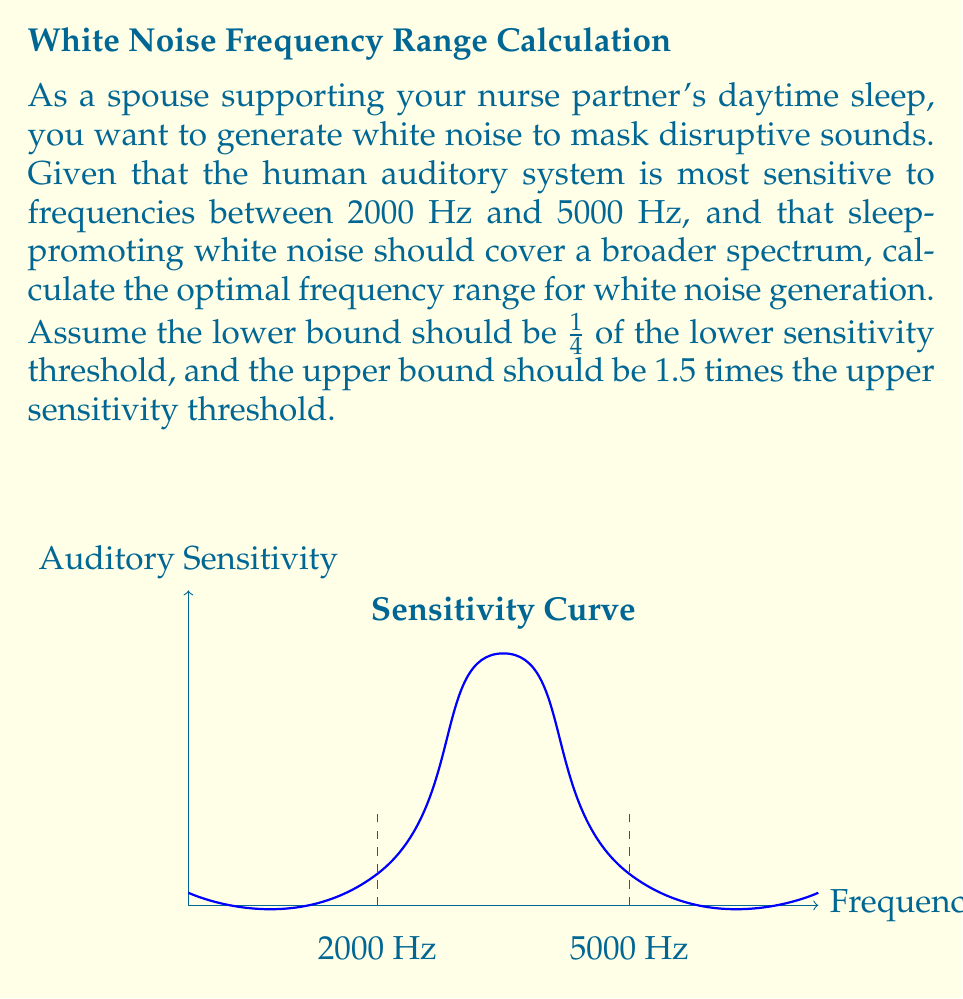Can you solve this math problem? To solve this problem, we'll follow these steps:

1) Identify the given sensitivity range:
   Lower threshold: 2000 Hz
   Upper threshold: 5000 Hz

2) Calculate the lower bound of the white noise range:
   Lower bound = 1/4 * Lower threshold
   $$ \text{Lower bound} = \frac{1}{4} \cdot 2000 \text{ Hz} = 500 \text{ Hz} $$

3) Calculate the upper bound of the white noise range:
   Upper bound = 1.5 * Upper threshold
   $$ \text{Upper bound} = 1.5 \cdot 5000 \text{ Hz} = 7500 \text{ Hz} $$

4) Express the result as a range:
   The optimal frequency range for white noise generation is 500 Hz to 7500 Hz.

This range ensures that the white noise covers frequencies below and above the most sensitive range of human hearing, providing effective masking of potential disturbances while promoting sleep.
Answer: 500 Hz - 7500 Hz 